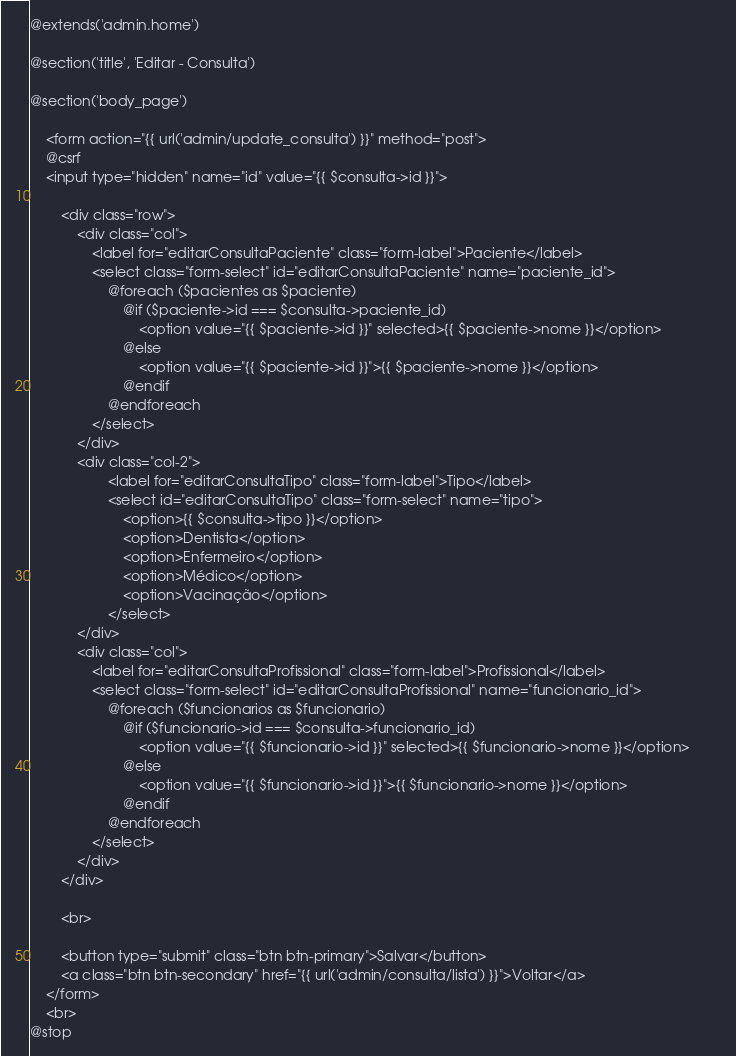<code> <loc_0><loc_0><loc_500><loc_500><_PHP_>@extends('admin.home')

@section('title', 'Editar - Consulta')

@section('body_page')

    <form action="{{ url('admin/update_consulta') }}" method="post">
    @csrf
    <input type="hidden" name="id" value="{{ $consulta->id }}">

        <div class="row">
            <div class="col">
                <label for="editarConsultaPaciente" class="form-label">Paciente</label>
                <select class="form-select" id="editarConsultaPaciente" name="paciente_id">
                    @foreach ($pacientes as $paciente)
                        @if ($paciente->id === $consulta->paciente_id)
                            <option value="{{ $paciente->id }}" selected>{{ $paciente->nome }}</option>    
                        @else
                            <option value="{{ $paciente->id }}">{{ $paciente->nome }}</option>        
                        @endif
                    @endforeach
                </select>
            </div>
            <div class="col-2">
                    <label for="editarConsultaTipo" class="form-label">Tipo</label>
                    <select id="editarConsultaTipo" class="form-select" name="tipo">
                        <option>{{ $consulta->tipo }}</option>
                        <option>Dentista</option>
                        <option>Enfermeiro</option>
                        <option>Médico</option>
                        <option>Vacinação</option>
                    </select>
            </div>
            <div class="col">
                <label for="editarConsultaProfissional" class="form-label">Profissional</label>
                <select class="form-select" id="editarConsultaProfissional" name="funcionario_id">
                    @foreach ($funcionarios as $funcionario)
                        @if ($funcionario->id === $consulta->funcionario_id)
                            <option value="{{ $funcionario->id }}" selected>{{ $funcionario->nome }}</option>        
                        @else
                            <option value="{{ $funcionario->id }}">{{ $funcionario->nome }}</option>  
                        @endif
                    @endforeach
                </select>
            </div>
        </div>

        <br>

        <button type="submit" class="btn btn-primary">Salvar</button> 
        <a class="btn btn-secondary" href="{{ url('admin/consulta/lista') }}">Voltar</a> 
    </form>
    <br>
@stop</code> 